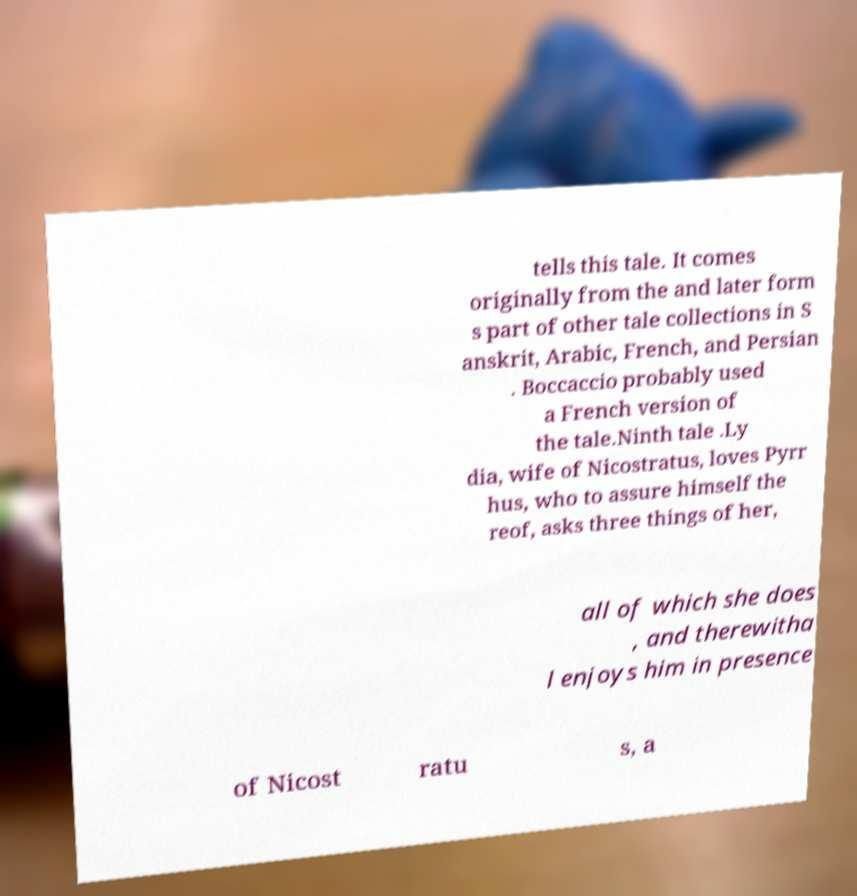There's text embedded in this image that I need extracted. Can you transcribe it verbatim? tells this tale. It comes originally from the and later form s part of other tale collections in S anskrit, Arabic, French, and Persian . Boccaccio probably used a French version of the tale.Ninth tale .Ly dia, wife of Nicostratus, loves Pyrr hus, who to assure himself the reof, asks three things of her, all of which she does , and therewitha l enjoys him in presence of Nicost ratu s, a 